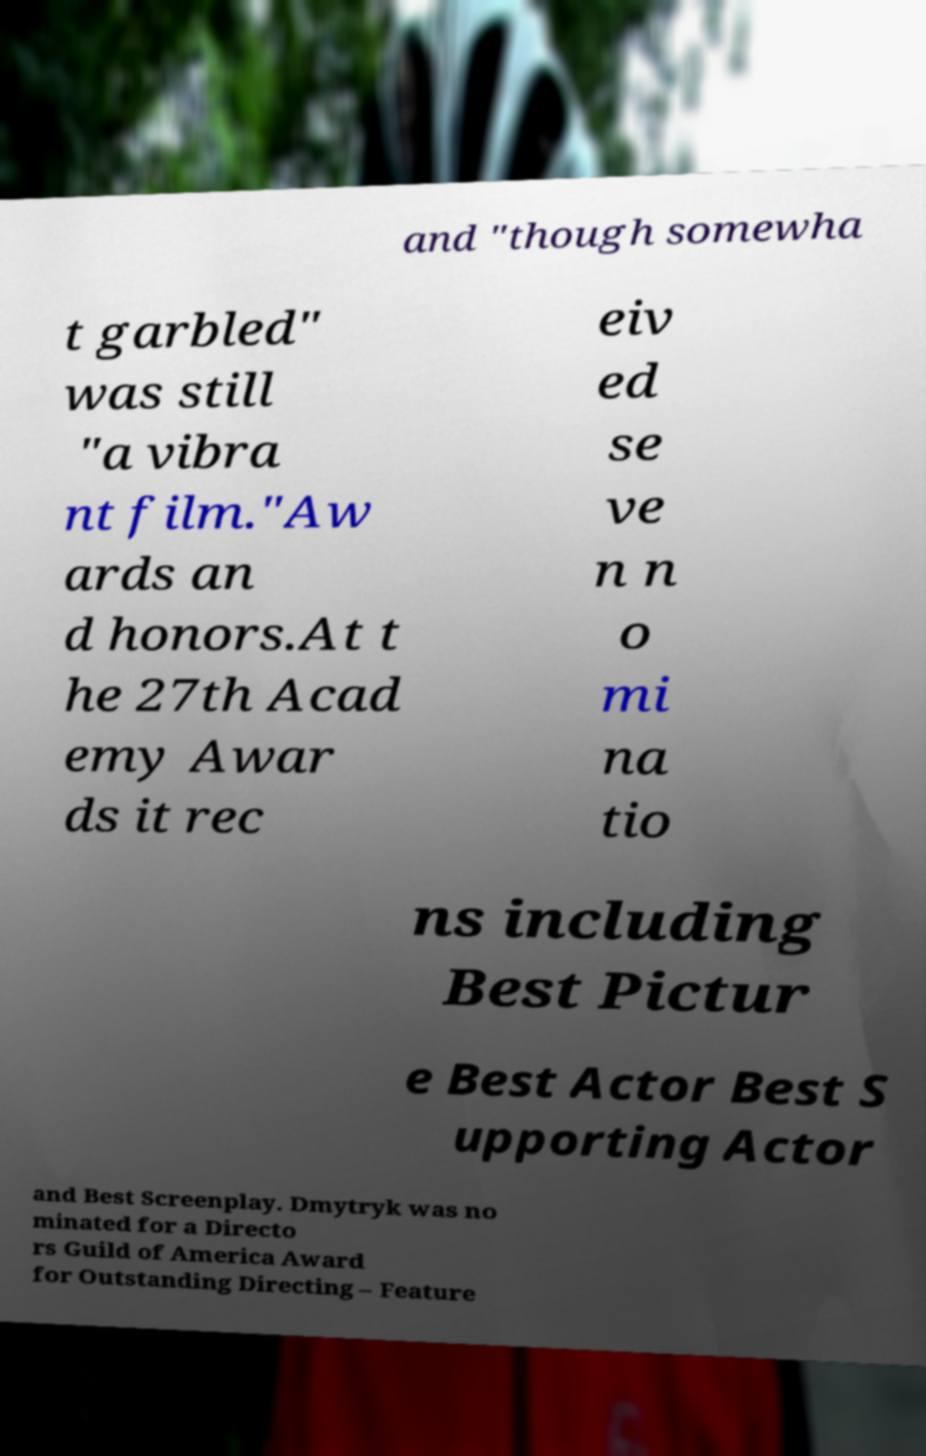Please read and relay the text visible in this image. What does it say? and "though somewha t garbled" was still "a vibra nt film."Aw ards an d honors.At t he 27th Acad emy Awar ds it rec eiv ed se ve n n o mi na tio ns including Best Pictur e Best Actor Best S upporting Actor and Best Screenplay. Dmytryk was no minated for a Directo rs Guild of America Award for Outstanding Directing – Feature 